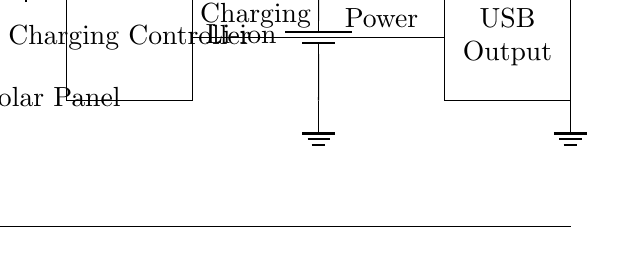What type of panel is used in this circuit? The circuit diagram labels the component as a "Solar Panel," indicating it converts sunlight into electrical energy.
Answer: Solar Panel What does the diode in the circuit do? The diode, specifically labeled "D1," allows current to flow in one direction and prevents the backflow, protecting the charging circuit from reverse polarity.
Answer: Protection How many main components are there in the circuit? The circuit includes five main components: Solar Panel, Diode, Charging Controller, Battery, and USB Output.
Answer: Five What is the output type of this charging circuit? The circuit features a "USB Output" component, indicating it is designed to charge mobile devices via USB.
Answer: USB What type of battery is used in this circuit? The battery is labeled as a "Li-ion," meaning it is a lithium-ion battery which is commonly used for portable electronics.
Answer: Li-ion What purpose does the charging controller serve in this circuit? The charging controller is essential for managing the flow of energy from the solar panel to the battery, ensuring proper charging and preventing overcharging.
Answer: Charging What is the configuration of the ground connections in the circuit? The ground connections are made at three points: the solar panel, the battery, and the USB output, ensuring a common reference point for the circuit.
Answer: Common ground 